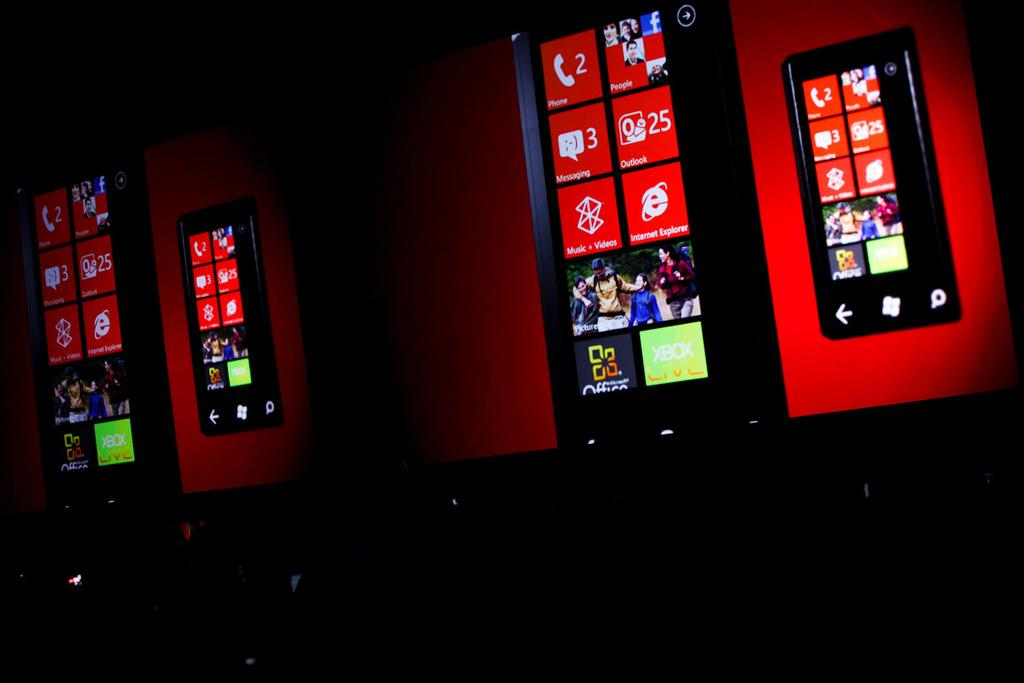Provide a one-sentence caption for the provided image. Phone screens show tiles including that someone has 3 messages and 25 emails on Outlook. 